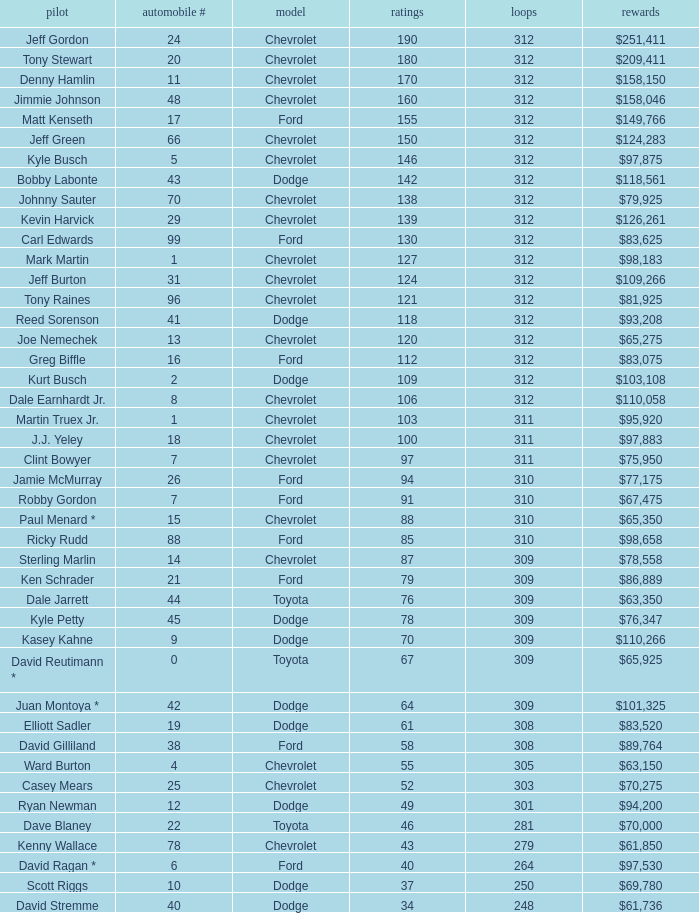What is the sum of laps that has a car number of larger than 1, is a ford, and has 155 points? 312.0. 